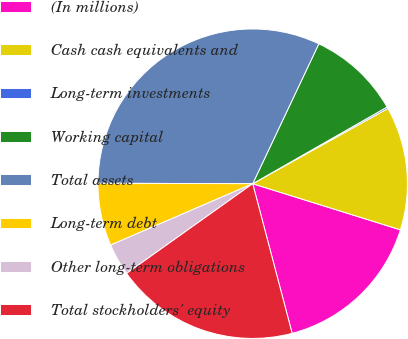Convert chart. <chart><loc_0><loc_0><loc_500><loc_500><pie_chart><fcel>(In millions)<fcel>Cash cash equivalents and<fcel>Long-term investments<fcel>Working capital<fcel>Total assets<fcel>Long-term debt<fcel>Other long-term obligations<fcel>Total stockholders' equity<nl><fcel>16.08%<fcel>12.9%<fcel>0.17%<fcel>9.72%<fcel>31.98%<fcel>6.54%<fcel>3.35%<fcel>19.26%<nl></chart> 